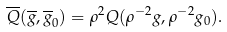Convert formula to latex. <formula><loc_0><loc_0><loc_500><loc_500>\overline { Q } ( \overline { g } , \overline { g } _ { 0 } ) = \rho ^ { 2 } Q ( \rho ^ { - 2 } g , \rho ^ { - 2 } g _ { 0 } ) .</formula> 